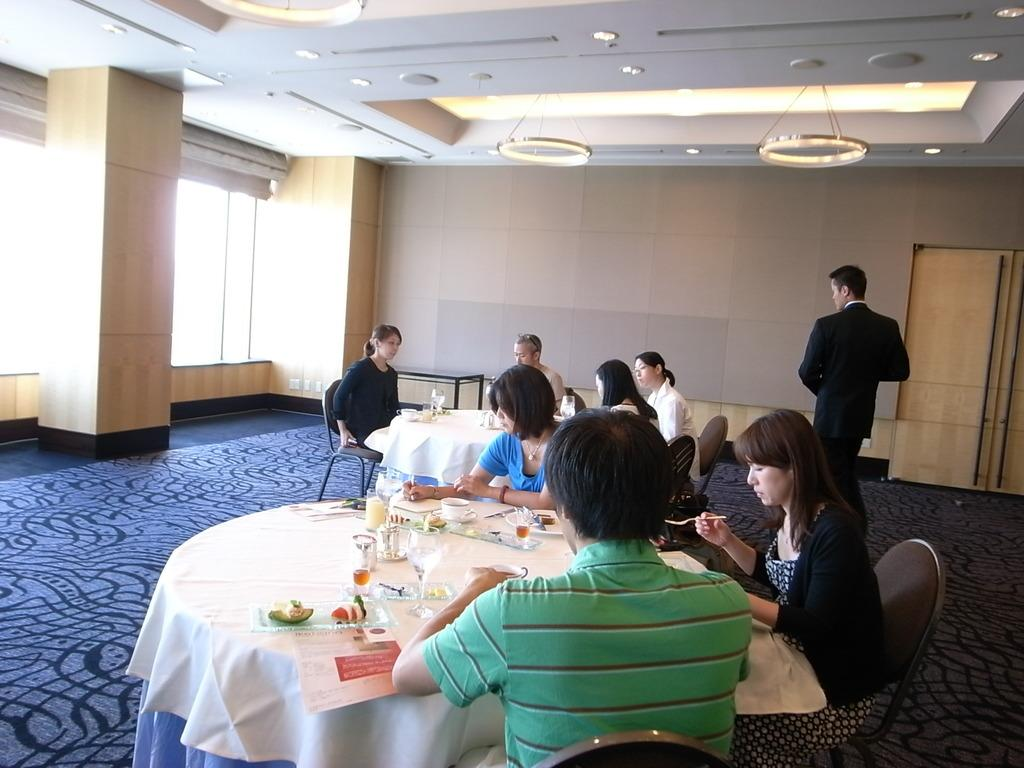What are the people in the image doing? There is a group of people sitting in the image. What objects can be seen on the table in the image? There is a glass, a cup, a saucer, food on a plate, a paper, and a cloth on the table in the image. What can be found on the roof in the image? There are lights on the roof in the image. What is the entrance feature in the image? There is a door in the image. What achievement did the achiever accomplish in the image? There is no mention of an achiever or any achievements in the image. What is the grandfather doing in the image? There is no mention of a grandfather or any specific actions in the image. 